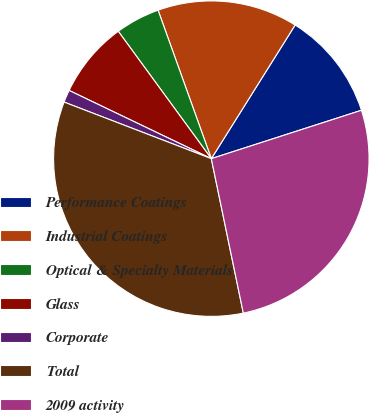Convert chart. <chart><loc_0><loc_0><loc_500><loc_500><pie_chart><fcel>Performance Coatings<fcel>Industrial Coatings<fcel>Optical & Specialty Materials<fcel>Glass<fcel>Corporate<fcel>Total<fcel>2009 activity<nl><fcel>11.12%<fcel>14.4%<fcel>4.56%<fcel>7.84%<fcel>1.28%<fcel>34.09%<fcel>26.71%<nl></chart> 